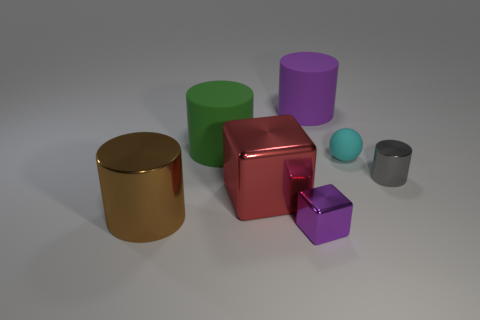Subtract all tiny metal cylinders. How many cylinders are left? 3 Subtract all green cylinders. How many cylinders are left? 3 Add 1 tiny red cylinders. How many objects exist? 8 Subtract all cyan cylinders. Subtract all gray cubes. How many cylinders are left? 4 Subtract all spheres. How many objects are left? 6 Add 5 cyan objects. How many cyan objects exist? 6 Subtract 0 brown balls. How many objects are left? 7 Subtract all large matte objects. Subtract all cylinders. How many objects are left? 1 Add 6 red things. How many red things are left? 7 